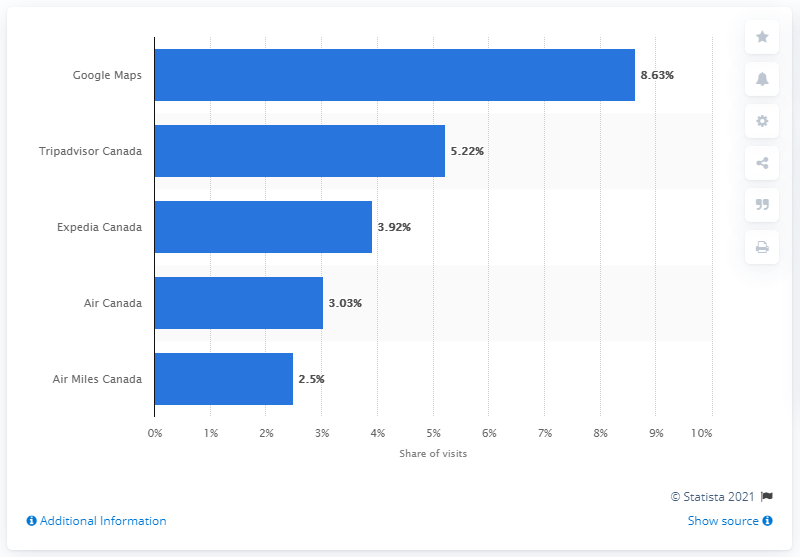Give some essential details in this illustration. Google Maps is the most popular website. The top three websites have a combined amount of approximately 17.77 shares. 